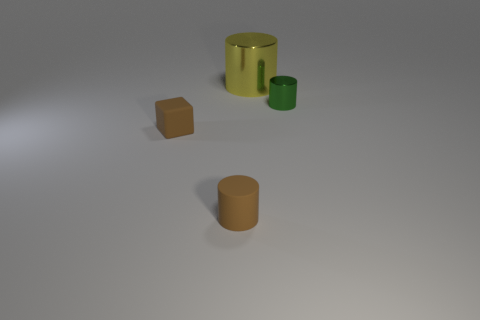There is a brown cube; is it the same size as the brown rubber thing in front of the brown block?
Your response must be concise. Yes. Are there an equal number of red cubes and yellow cylinders?
Your answer should be compact. No. There is a small matte thing left of the brown matte object that is in front of the block; how many small matte cylinders are behind it?
Provide a succinct answer. 0. What number of things are on the left side of the yellow object?
Your answer should be very brief. 2. There is a tiny cylinder that is in front of the small cylinder to the right of the yellow shiny cylinder; what color is it?
Provide a short and direct response. Brown. What number of other objects are the same material as the small block?
Provide a succinct answer. 1. Are there the same number of yellow metallic objects that are right of the large yellow metal object and large metal cylinders?
Your response must be concise. No. There is a tiny brown object behind the brown cylinder in front of the tiny green shiny cylinder that is to the right of the large yellow metallic cylinder; what is it made of?
Make the answer very short. Rubber. The metal cylinder in front of the large yellow cylinder is what color?
Make the answer very short. Green. Are there any other things that have the same shape as the big metal thing?
Offer a very short reply. Yes. 